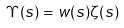<formula> <loc_0><loc_0><loc_500><loc_500>\Upsilon ( s ) = w ( s ) \zeta ( s )</formula> 